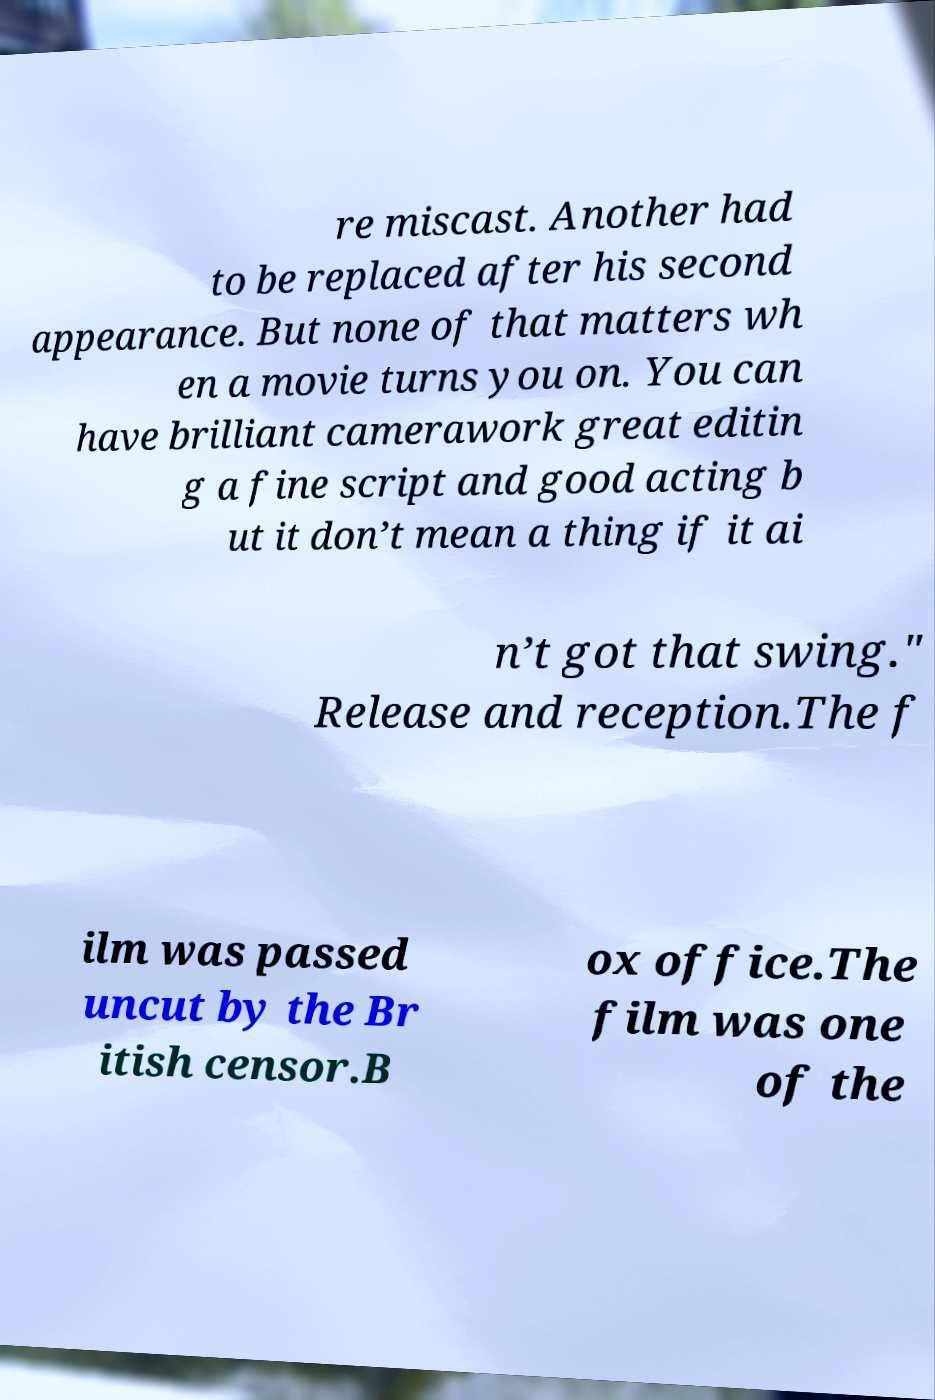Could you extract and type out the text from this image? re miscast. Another had to be replaced after his second appearance. But none of that matters wh en a movie turns you on. You can have brilliant camerawork great editin g a fine script and good acting b ut it don’t mean a thing if it ai n’t got that swing." Release and reception.The f ilm was passed uncut by the Br itish censor.B ox office.The film was one of the 